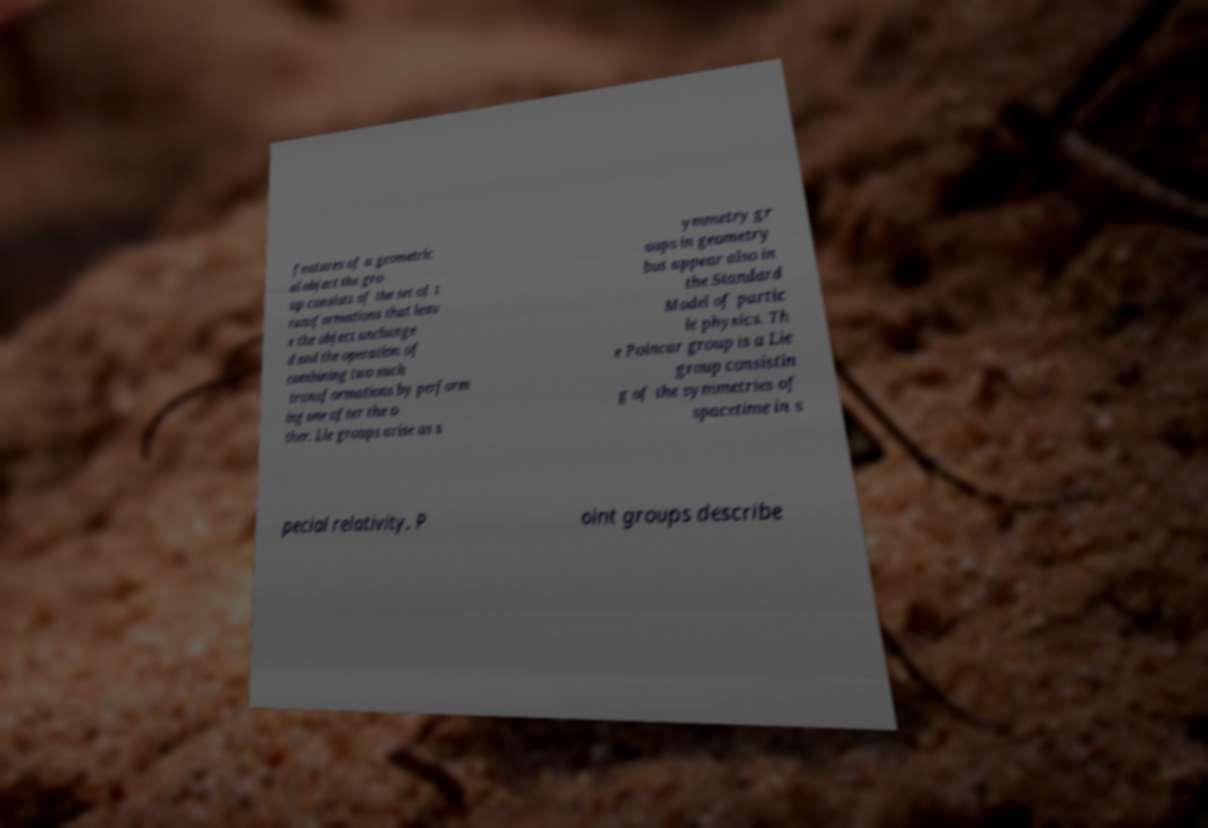Could you assist in decoding the text presented in this image and type it out clearly? features of a geometric al object the gro up consists of the set of t ransformations that leav e the object unchange d and the operation of combining two such transformations by perform ing one after the o ther. Lie groups arise as s ymmetry gr oups in geometry but appear also in the Standard Model of partic le physics. Th e Poincar group is a Lie group consistin g of the symmetries of spacetime in s pecial relativity. P oint groups describe 